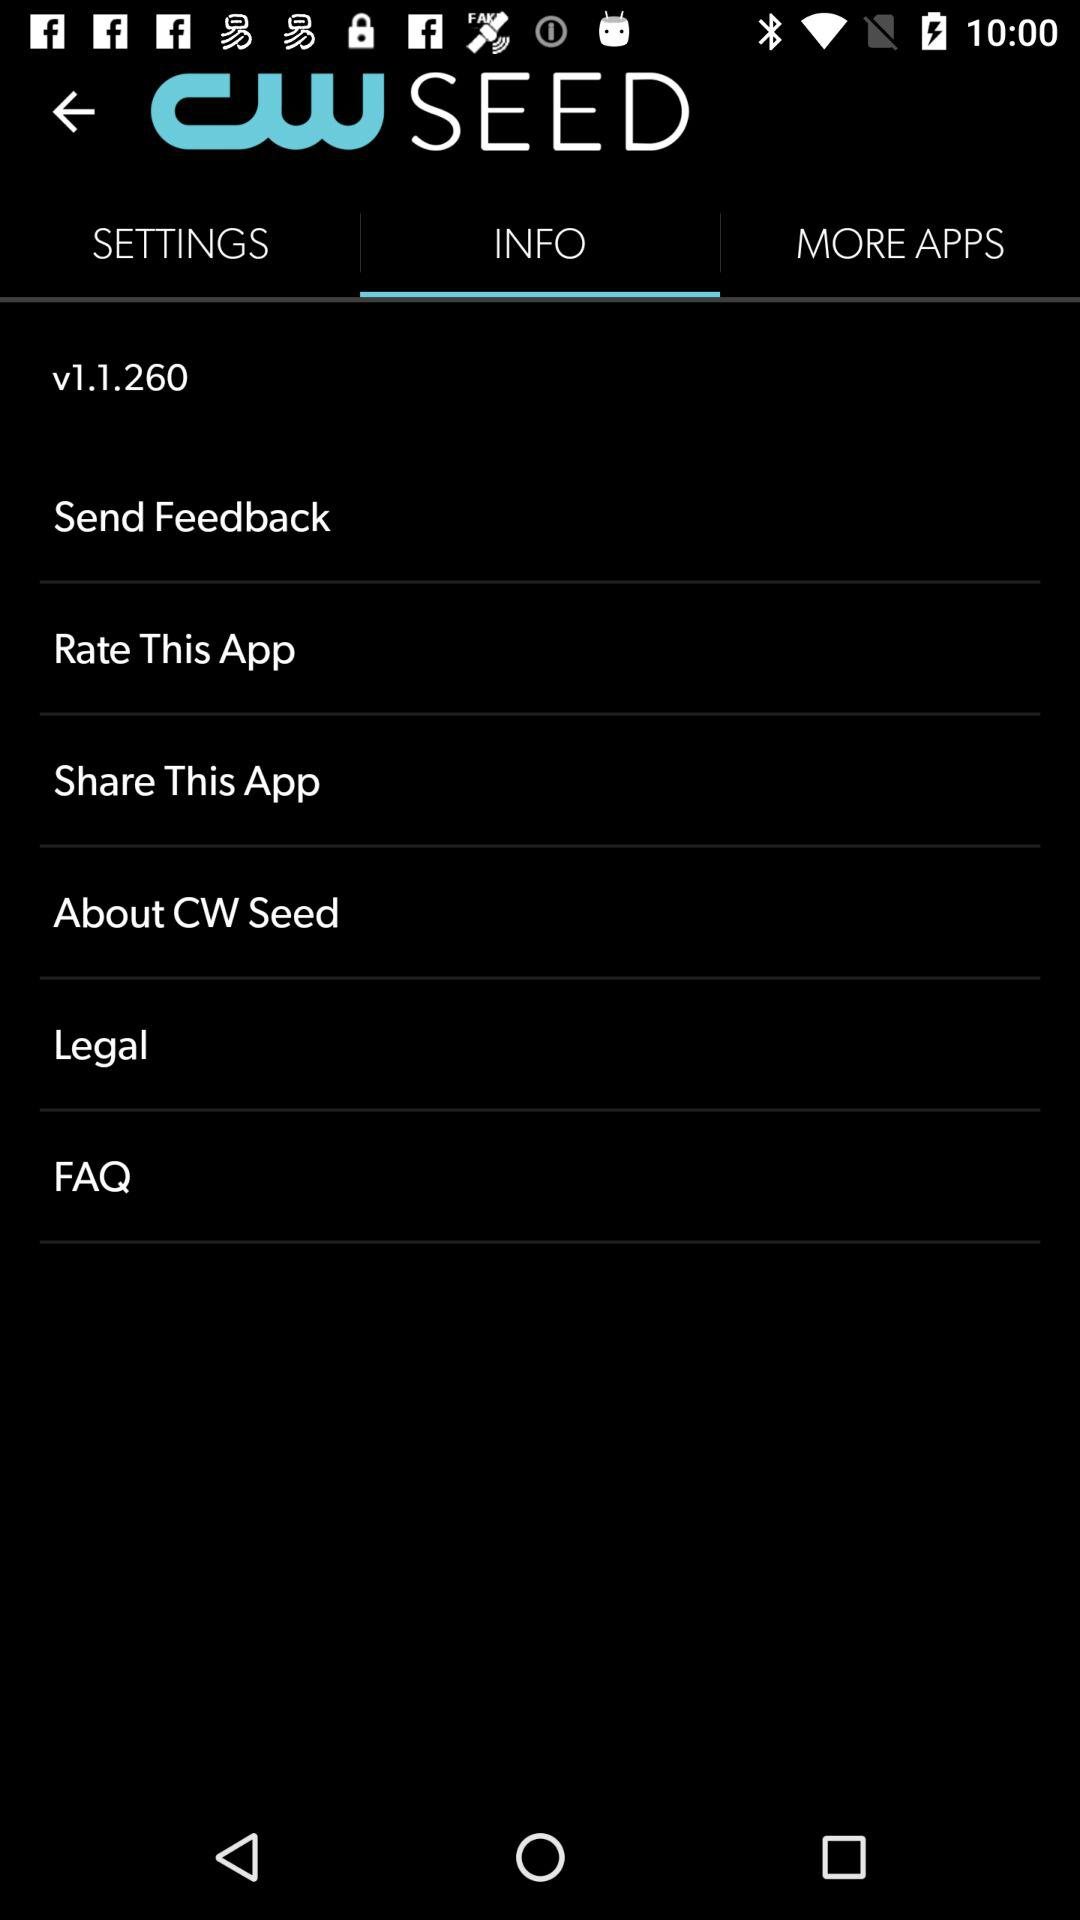What is the application name? The application name is "CW SEED". 